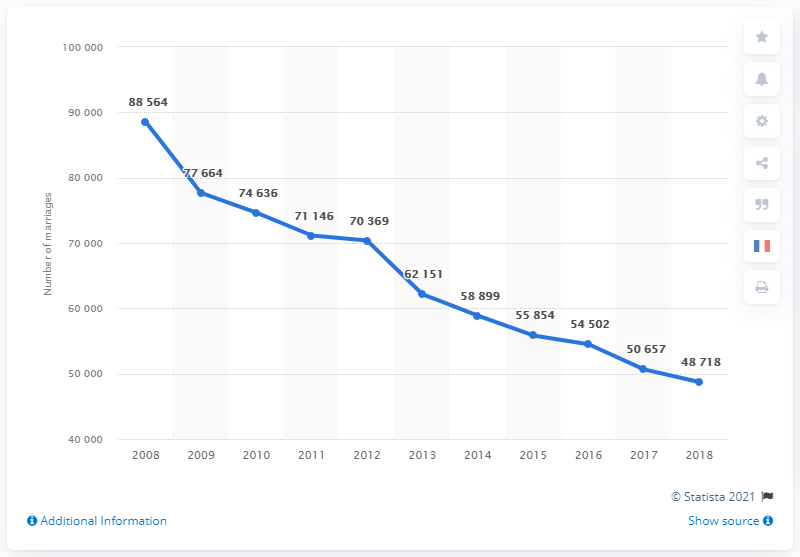Identify some key points in this picture. The number of marriages is decreasing. Since 2008, the number of Catholic marriages has decreased in France. The sum of 2017 and 2018 is equal to 99375. 